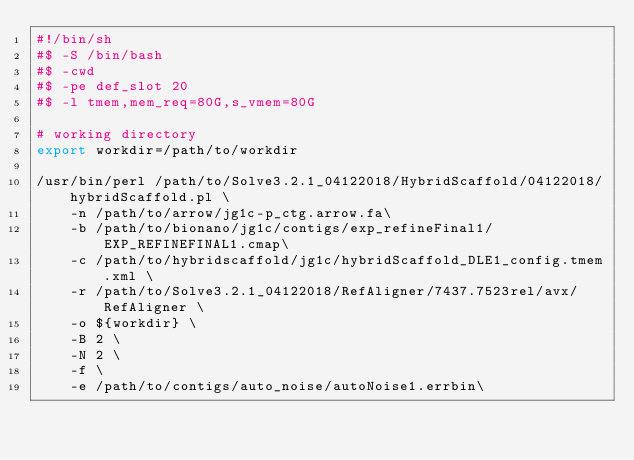Convert code to text. <code><loc_0><loc_0><loc_500><loc_500><_Bash_>#!/bin/sh
#$ -S /bin/bash
#$ -cwd
#$ -pe def_slot 20
#$ -l tmem,mem_req=80G,s_vmem=80G

# working directory
export workdir=/path/to/workdir

/usr/bin/perl /path/to/Solve3.2.1_04122018/HybridScaffold/04122018/hybridScaffold.pl \
	-n /path/to/arrow/jg1c-p_ctg.arrow.fa\
	-b /path/to/bionano/jg1c/contigs/exp_refineFinal1/EXP_REFINEFINAL1.cmap\
	-c /path/to/hybridscaffold/jg1c/hybridScaffold_DLE1_config.tmem.xml \
	-r /path/to/Solve3.2.1_04122018/RefAligner/7437.7523rel/avx/RefAligner \
	-o ${workdir} \
	-B 2 \
	-N 2 \
	-f \
	-e /path/to/contigs/auto_noise/autoNoise1.errbin\</code> 